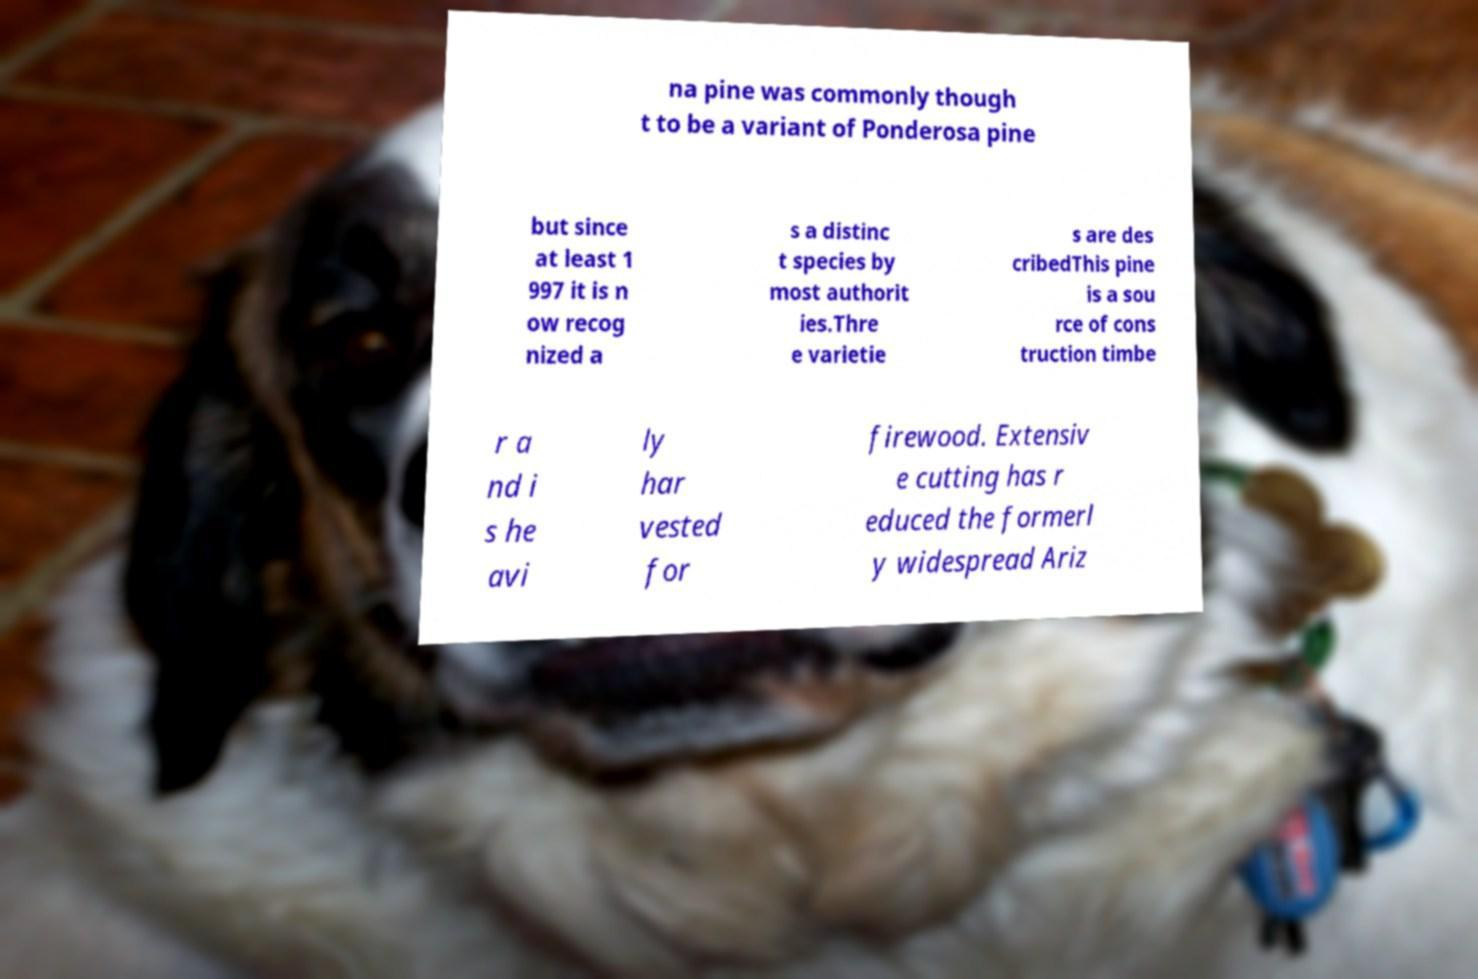What messages or text are displayed in this image? I need them in a readable, typed format. na pine was commonly though t to be a variant of Ponderosa pine but since at least 1 997 it is n ow recog nized a s a distinc t species by most authorit ies.Thre e varietie s are des cribedThis pine is a sou rce of cons truction timbe r a nd i s he avi ly har vested for firewood. Extensiv e cutting has r educed the formerl y widespread Ariz 